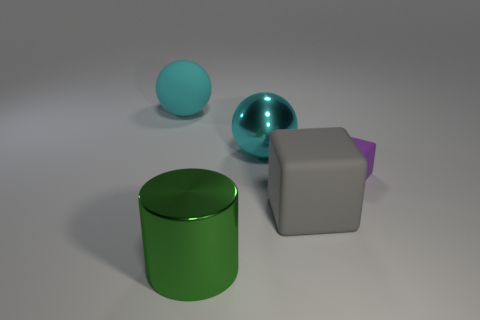Add 5 big cyan rubber spheres. How many objects exist? 10 Subtract all cylinders. How many objects are left? 4 Subtract 0 blue blocks. How many objects are left? 5 Subtract all rubber balls. Subtract all blocks. How many objects are left? 2 Add 1 small purple blocks. How many small purple blocks are left? 2 Add 5 cyan balls. How many cyan balls exist? 7 